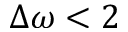Convert formula to latex. <formula><loc_0><loc_0><loc_500><loc_500>\Delta \omega < 2</formula> 